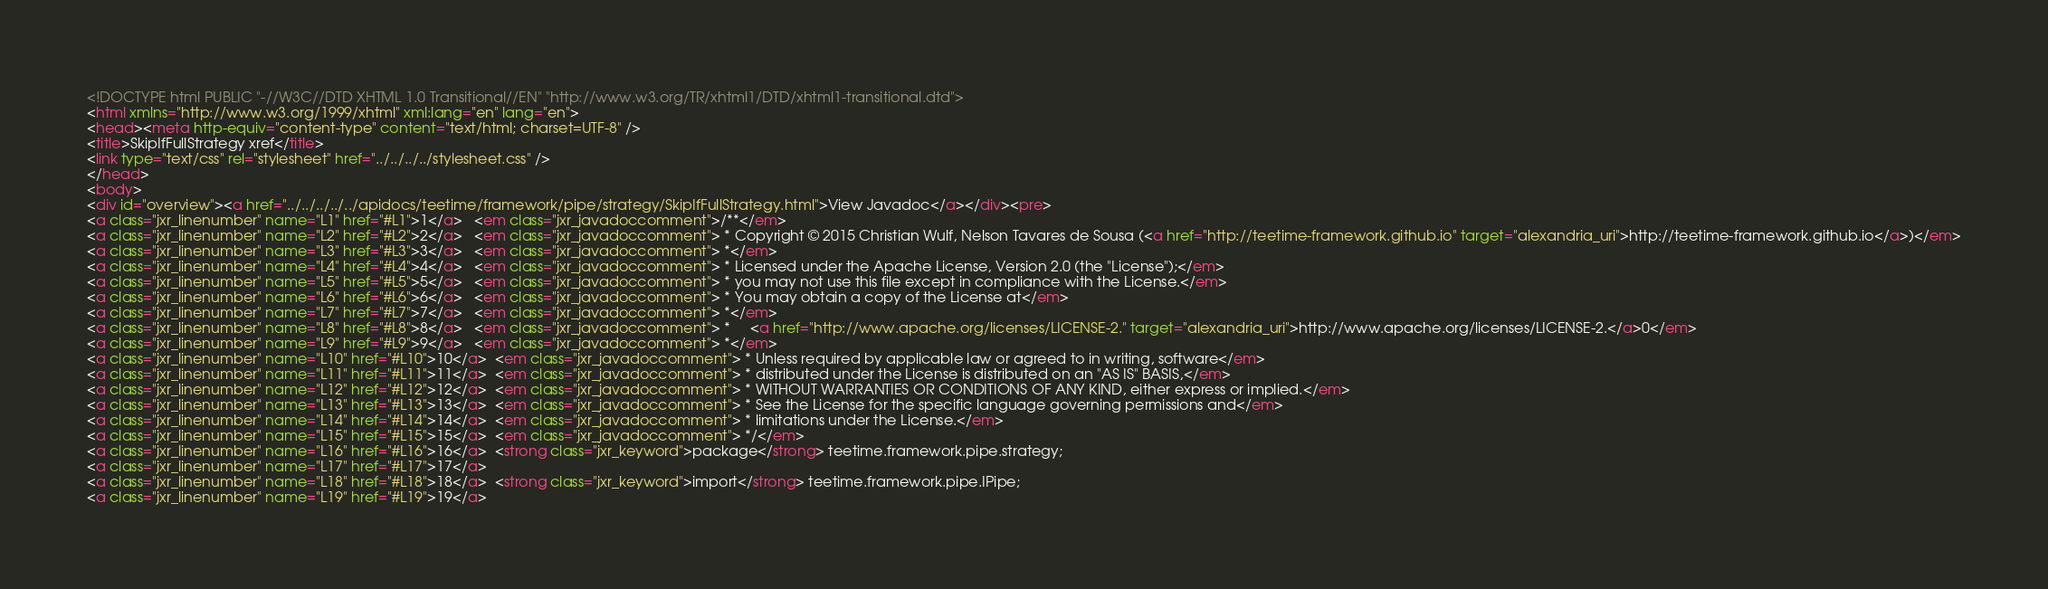Convert code to text. <code><loc_0><loc_0><loc_500><loc_500><_HTML_><!DOCTYPE html PUBLIC "-//W3C//DTD XHTML 1.0 Transitional//EN" "http://www.w3.org/TR/xhtml1/DTD/xhtml1-transitional.dtd">
<html xmlns="http://www.w3.org/1999/xhtml" xml:lang="en" lang="en">
<head><meta http-equiv="content-type" content="text/html; charset=UTF-8" />
<title>SkipIfFullStrategy xref</title>
<link type="text/css" rel="stylesheet" href="../../../../stylesheet.css" />
</head>
<body>
<div id="overview"><a href="../../../../../apidocs/teetime/framework/pipe/strategy/SkipIfFullStrategy.html">View Javadoc</a></div><pre>
<a class="jxr_linenumber" name="L1" href="#L1">1</a>   <em class="jxr_javadoccomment">/**</em>
<a class="jxr_linenumber" name="L2" href="#L2">2</a>   <em class="jxr_javadoccomment"> * Copyright © 2015 Christian Wulf, Nelson Tavares de Sousa (<a href="http://teetime-framework.github.io" target="alexandria_uri">http://teetime-framework.github.io</a>)</em>
<a class="jxr_linenumber" name="L3" href="#L3">3</a>   <em class="jxr_javadoccomment"> *</em>
<a class="jxr_linenumber" name="L4" href="#L4">4</a>   <em class="jxr_javadoccomment"> * Licensed under the Apache License, Version 2.0 (the "License");</em>
<a class="jxr_linenumber" name="L5" href="#L5">5</a>   <em class="jxr_javadoccomment"> * you may not use this file except in compliance with the License.</em>
<a class="jxr_linenumber" name="L6" href="#L6">6</a>   <em class="jxr_javadoccomment"> * You may obtain a copy of the License at</em>
<a class="jxr_linenumber" name="L7" href="#L7">7</a>   <em class="jxr_javadoccomment"> *</em>
<a class="jxr_linenumber" name="L8" href="#L8">8</a>   <em class="jxr_javadoccomment"> *     <a href="http://www.apache.org/licenses/LICENSE-2." target="alexandria_uri">http://www.apache.org/licenses/LICENSE-2.</a>0</em>
<a class="jxr_linenumber" name="L9" href="#L9">9</a>   <em class="jxr_javadoccomment"> *</em>
<a class="jxr_linenumber" name="L10" href="#L10">10</a>  <em class="jxr_javadoccomment"> * Unless required by applicable law or agreed to in writing, software</em>
<a class="jxr_linenumber" name="L11" href="#L11">11</a>  <em class="jxr_javadoccomment"> * distributed under the License is distributed on an "AS IS" BASIS,</em>
<a class="jxr_linenumber" name="L12" href="#L12">12</a>  <em class="jxr_javadoccomment"> * WITHOUT WARRANTIES OR CONDITIONS OF ANY KIND, either express or implied.</em>
<a class="jxr_linenumber" name="L13" href="#L13">13</a>  <em class="jxr_javadoccomment"> * See the License for the specific language governing permissions and</em>
<a class="jxr_linenumber" name="L14" href="#L14">14</a>  <em class="jxr_javadoccomment"> * limitations under the License.</em>
<a class="jxr_linenumber" name="L15" href="#L15">15</a>  <em class="jxr_javadoccomment"> */</em>
<a class="jxr_linenumber" name="L16" href="#L16">16</a>  <strong class="jxr_keyword">package</strong> teetime.framework.pipe.strategy;
<a class="jxr_linenumber" name="L17" href="#L17">17</a>  
<a class="jxr_linenumber" name="L18" href="#L18">18</a>  <strong class="jxr_keyword">import</strong> teetime.framework.pipe.IPipe;
<a class="jxr_linenumber" name="L19" href="#L19">19</a>  </code> 